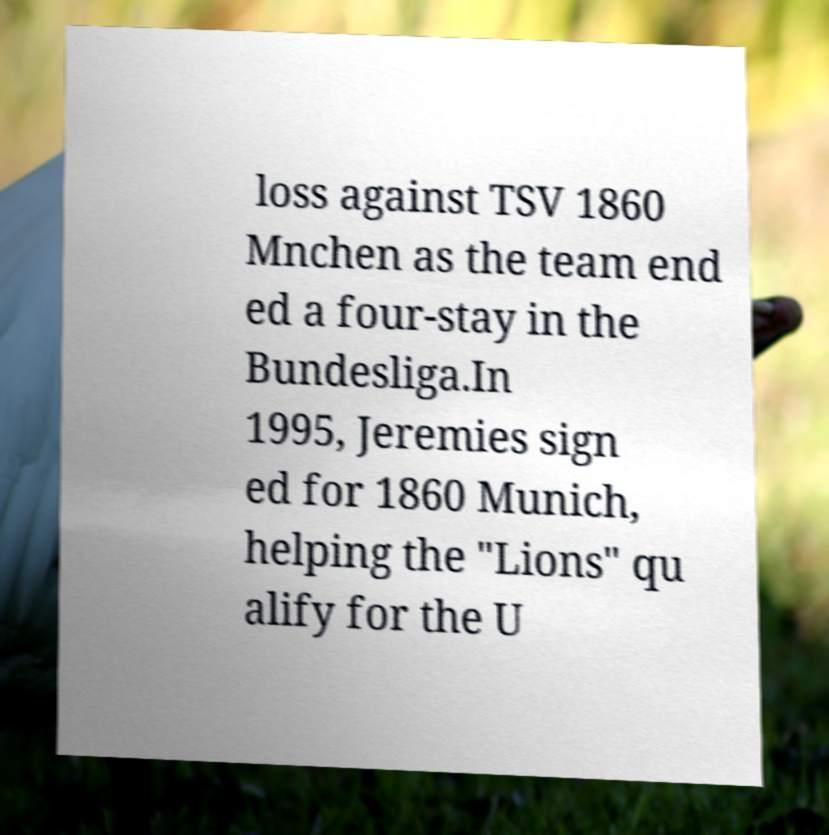Could you extract and type out the text from this image? loss against TSV 1860 Mnchen as the team end ed a four-stay in the Bundesliga.In 1995, Jeremies sign ed for 1860 Munich, helping the "Lions" qu alify for the U 